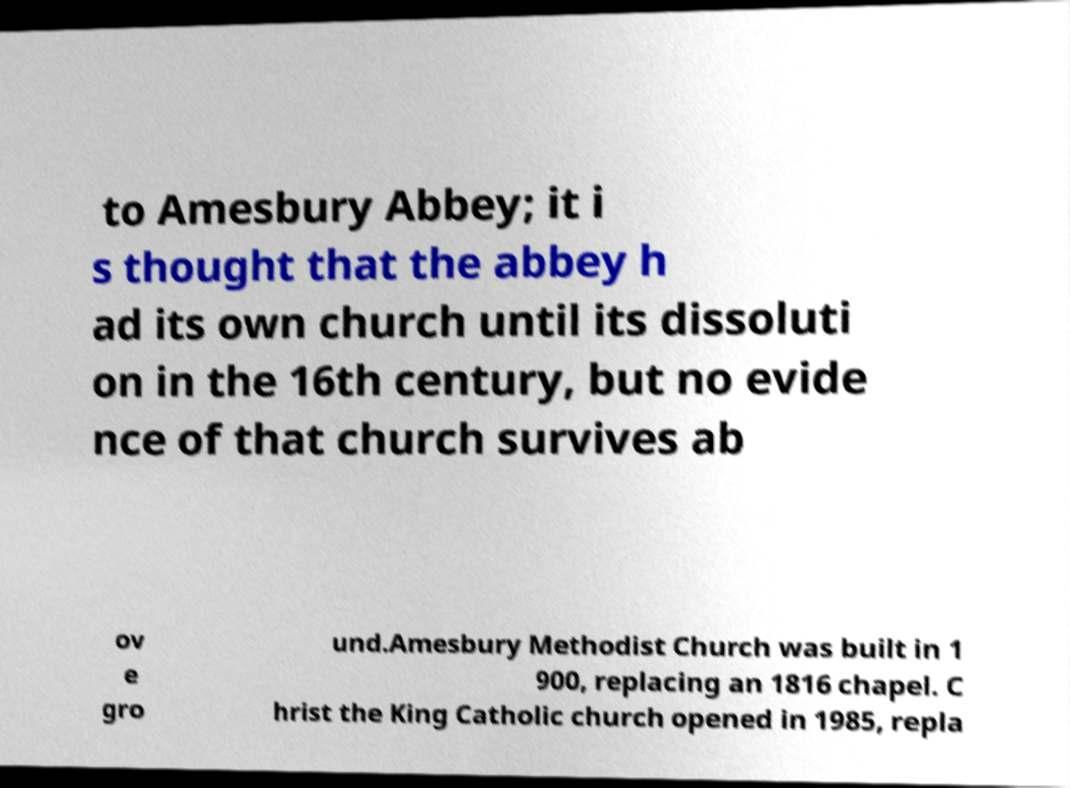Could you assist in decoding the text presented in this image and type it out clearly? to Amesbury Abbey; it i s thought that the abbey h ad its own church until its dissoluti on in the 16th century, but no evide nce of that church survives ab ov e gro und.Amesbury Methodist Church was built in 1 900, replacing an 1816 chapel. C hrist the King Catholic church opened in 1985, repla 